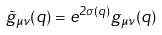<formula> <loc_0><loc_0><loc_500><loc_500>\tilde { g } _ { \mu \nu } ( q ) = e ^ { 2 \sigma ( q ) } { g } _ { \mu \nu } ( q )</formula> 